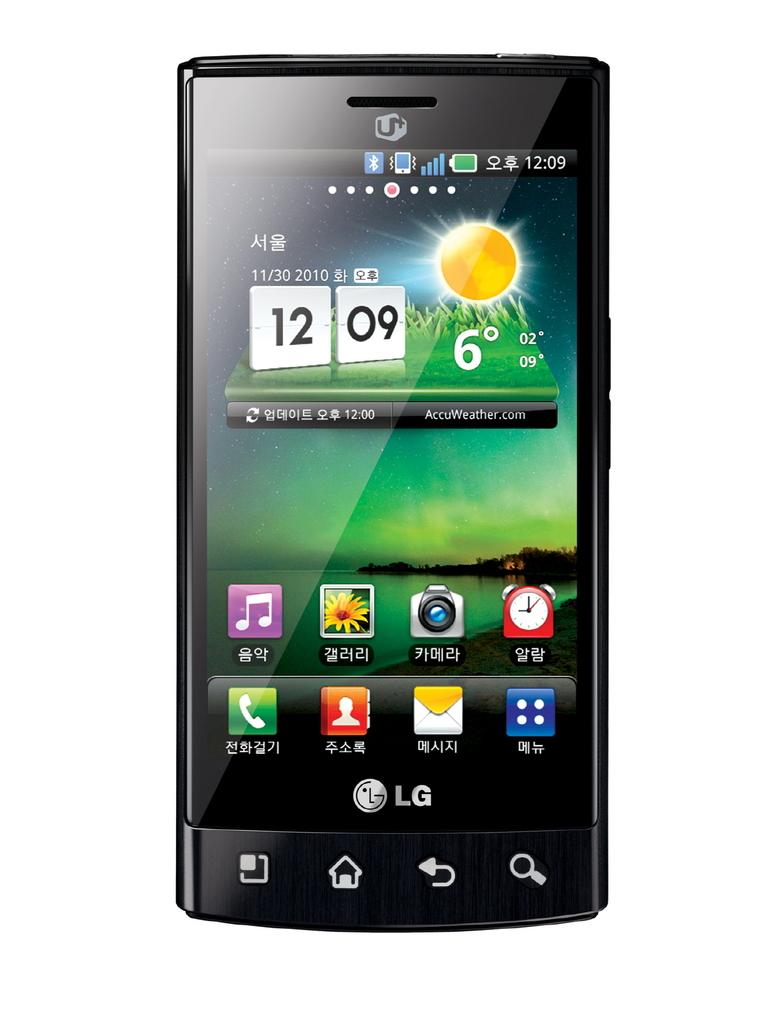What time is on the phone?
Offer a terse response. 12:09. Wow nice lg phone?
Ensure brevity in your answer.  Yes. 